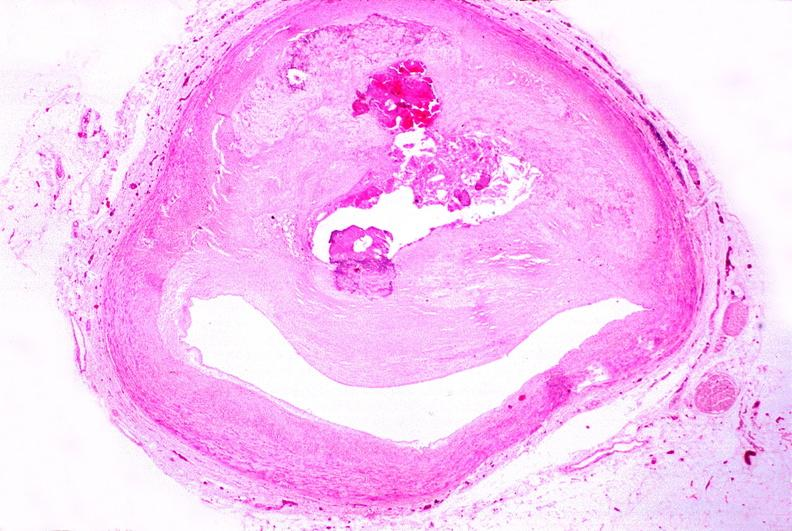does this section showing liver with tumor mass in hilar area tumor show atherosclerosis?
Answer the question using a single word or phrase. No 